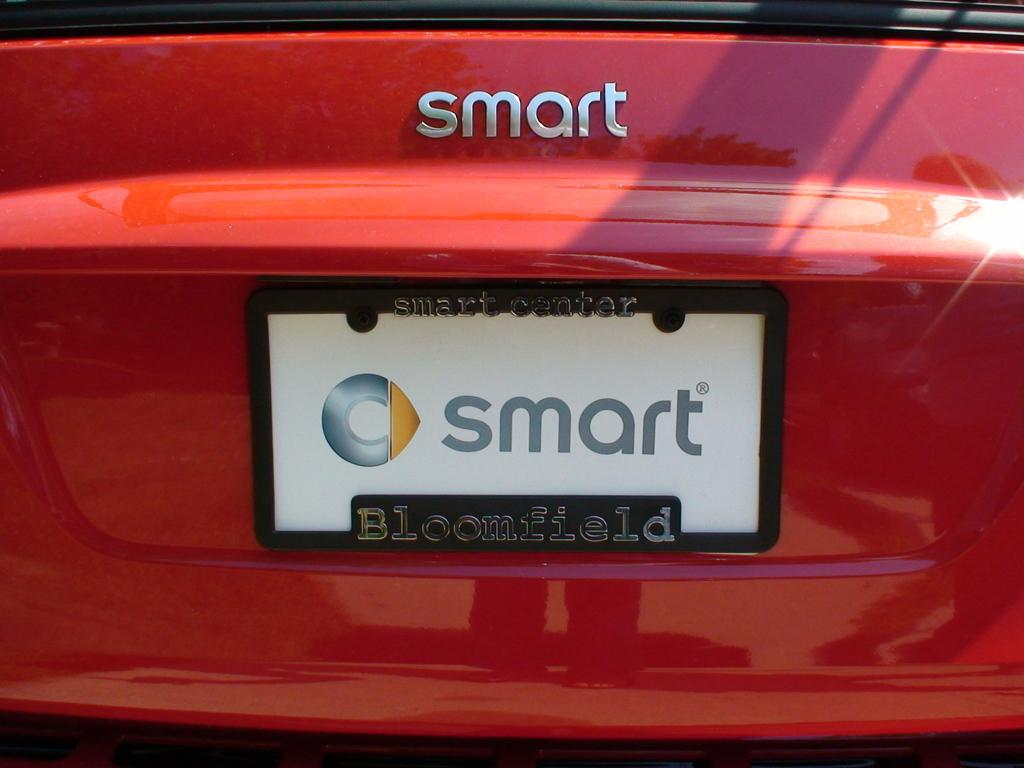Provide a one-sentence caption for the provided image. The rear end of a red car says "smart" on it above a license plate that also says "smart" on it. 